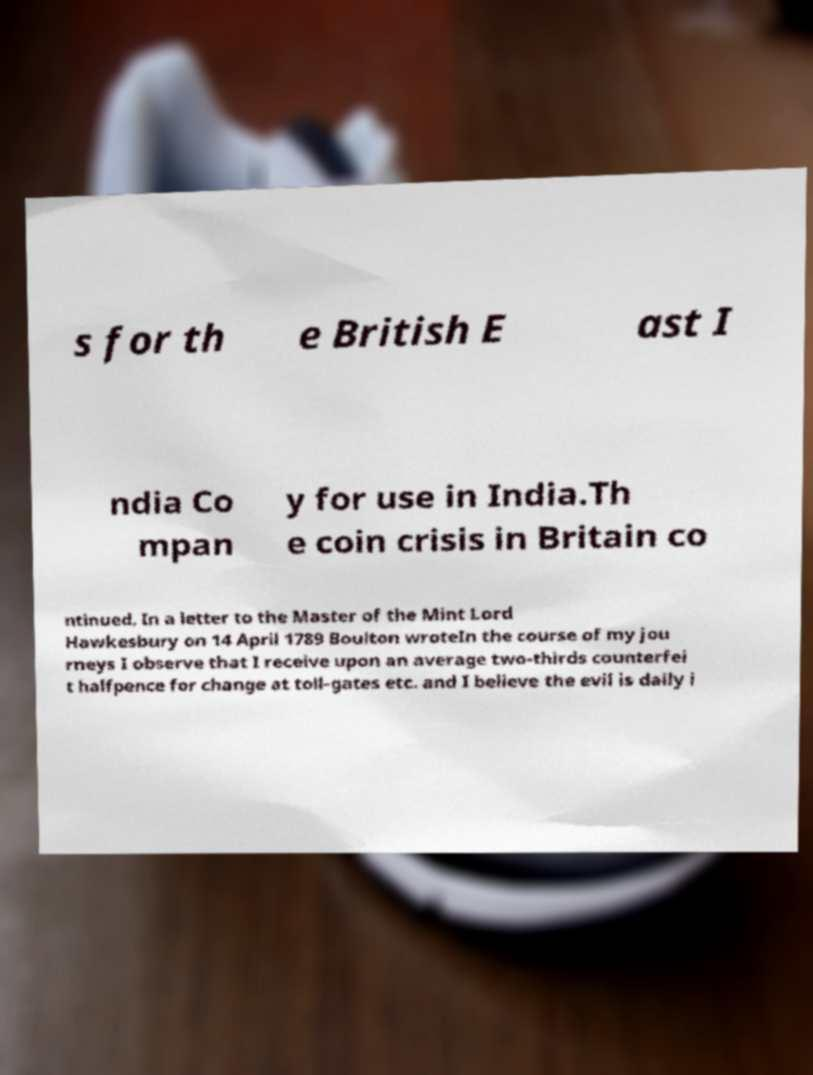Could you assist in decoding the text presented in this image and type it out clearly? s for th e British E ast I ndia Co mpan y for use in India.Th e coin crisis in Britain co ntinued. In a letter to the Master of the Mint Lord Hawkesbury on 14 April 1789 Boulton wroteIn the course of my jou rneys I observe that I receive upon an average two-thirds counterfei t halfpence for change at toll-gates etc. and I believe the evil is daily i 